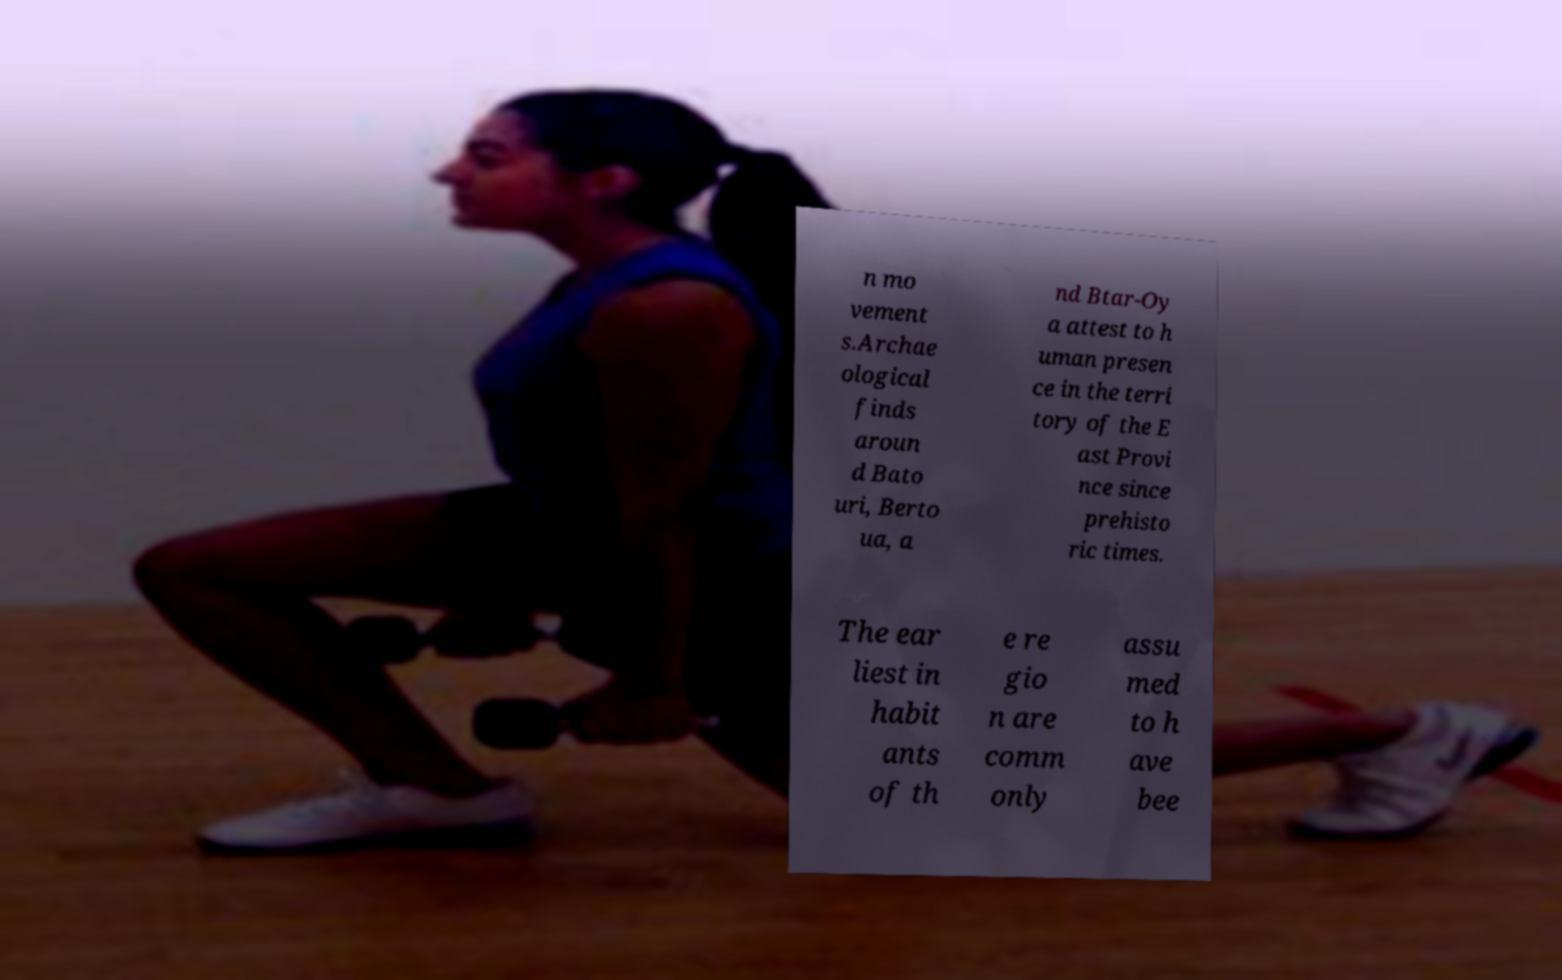I need the written content from this picture converted into text. Can you do that? n mo vement s.Archae ological finds aroun d Bato uri, Berto ua, a nd Btar-Oy a attest to h uman presen ce in the terri tory of the E ast Provi nce since prehisto ric times. The ear liest in habit ants of th e re gio n are comm only assu med to h ave bee 